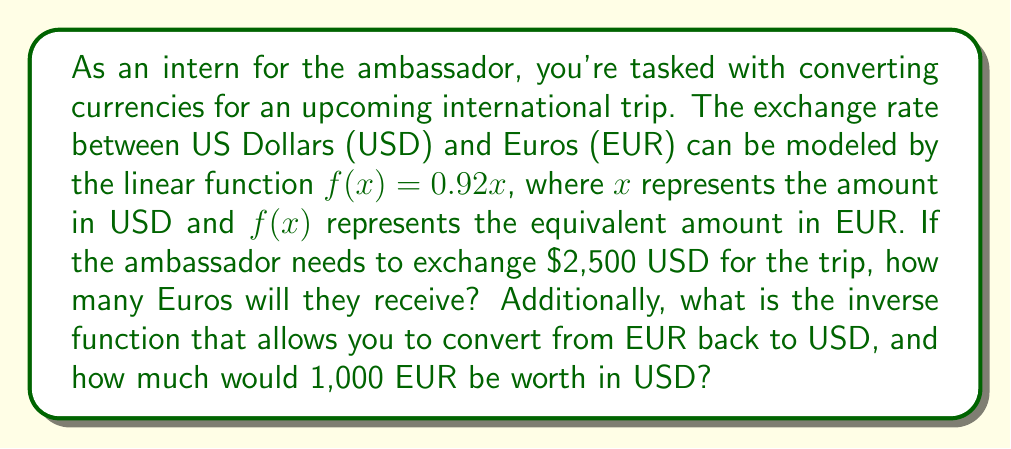Solve this math problem. To solve this problem, we'll use the given linear function and its properties:

1. Calculate the EUR equivalent of $2,500 USD:
   $$f(x) = 0.92x$$
   $$f(2500) = 0.92 \cdot 2500 = 2300$$

2. To find the inverse function, we need to swap $x$ and $y$ (or $f(x)$) and solve for $y$:
   $$y = 0.92x$$
   $$x = 0.92y$$
   $$\frac{x}{0.92} = y$$
   $$f^{-1}(x) = \frac{x}{0.92} \approx 1.0870x$$

3. To convert 1,000 EUR to USD using the inverse function:
   $$f^{-1}(1000) = \frac{1000}{0.92} \approx 1086.96$$
Answer: The ambassador will receive 2,300 EUR for $2,500 USD. The inverse function to convert from EUR to USD is $f^{-1}(x) = \frac{x}{0.92}$. Using this function, 1,000 EUR is equivalent to approximately $1,086.96 USD. 